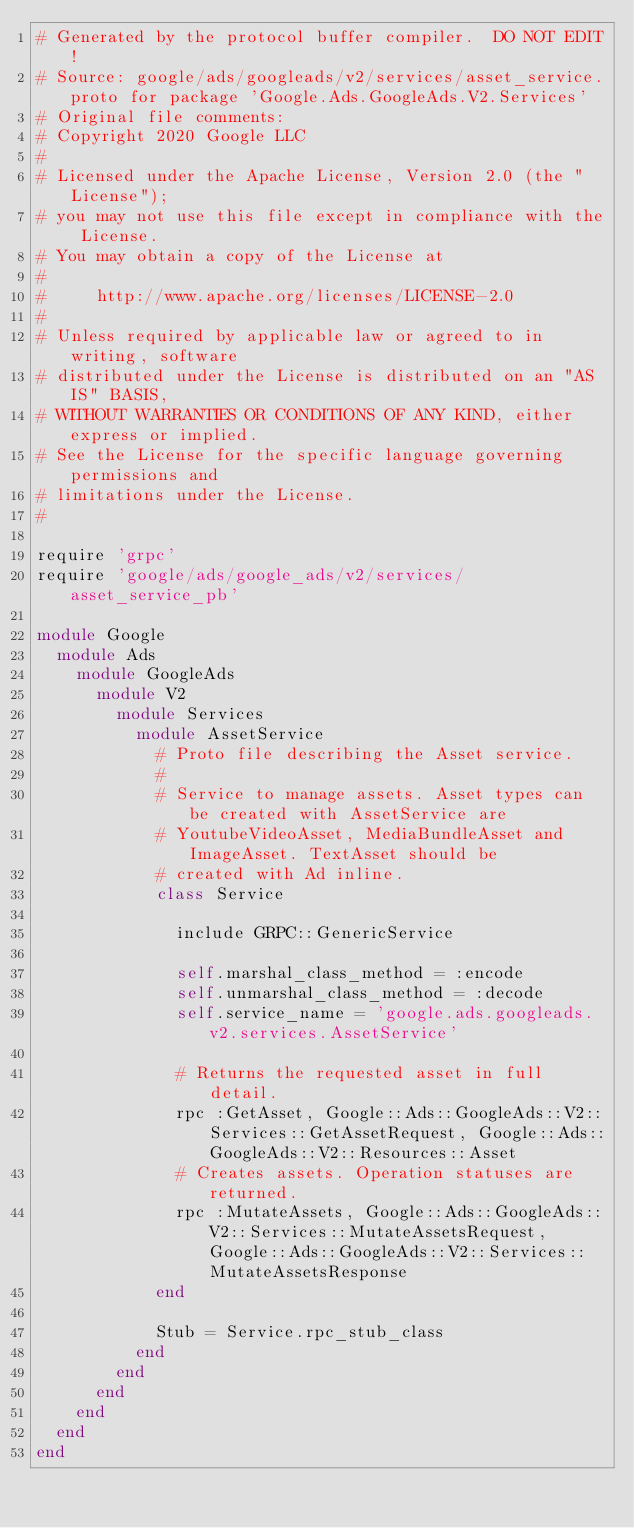Convert code to text. <code><loc_0><loc_0><loc_500><loc_500><_Ruby_># Generated by the protocol buffer compiler.  DO NOT EDIT!
# Source: google/ads/googleads/v2/services/asset_service.proto for package 'Google.Ads.GoogleAds.V2.Services'
# Original file comments:
# Copyright 2020 Google LLC
#
# Licensed under the Apache License, Version 2.0 (the "License");
# you may not use this file except in compliance with the License.
# You may obtain a copy of the License at
#
#     http://www.apache.org/licenses/LICENSE-2.0
#
# Unless required by applicable law or agreed to in writing, software
# distributed under the License is distributed on an "AS IS" BASIS,
# WITHOUT WARRANTIES OR CONDITIONS OF ANY KIND, either express or implied.
# See the License for the specific language governing permissions and
# limitations under the License.
#

require 'grpc'
require 'google/ads/google_ads/v2/services/asset_service_pb'

module Google
  module Ads
    module GoogleAds
      module V2
        module Services
          module AssetService
            # Proto file describing the Asset service.
            #
            # Service to manage assets. Asset types can be created with AssetService are
            # YoutubeVideoAsset, MediaBundleAsset and ImageAsset. TextAsset should be
            # created with Ad inline.
            class Service

              include GRPC::GenericService

              self.marshal_class_method = :encode
              self.unmarshal_class_method = :decode
              self.service_name = 'google.ads.googleads.v2.services.AssetService'

              # Returns the requested asset in full detail.
              rpc :GetAsset, Google::Ads::GoogleAds::V2::Services::GetAssetRequest, Google::Ads::GoogleAds::V2::Resources::Asset
              # Creates assets. Operation statuses are returned.
              rpc :MutateAssets, Google::Ads::GoogleAds::V2::Services::MutateAssetsRequest, Google::Ads::GoogleAds::V2::Services::MutateAssetsResponse
            end

            Stub = Service.rpc_stub_class
          end
        end
      end
    end
  end
end
</code> 